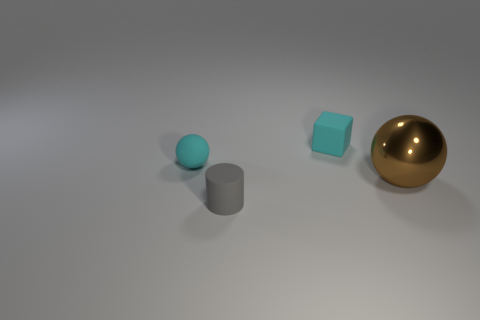What kind of materials could these objects be made from in real life? The objects resemble common materials found in the real world. The small teal sphere and the slightly translucent cube could be made of plastic or colored glass, while the matte gray cylinder might be ceramic or stone due to its non-reflective surface. The golden sphere appears to be metallic, as its surface is highly reflective, similar to polished brass or gold. 